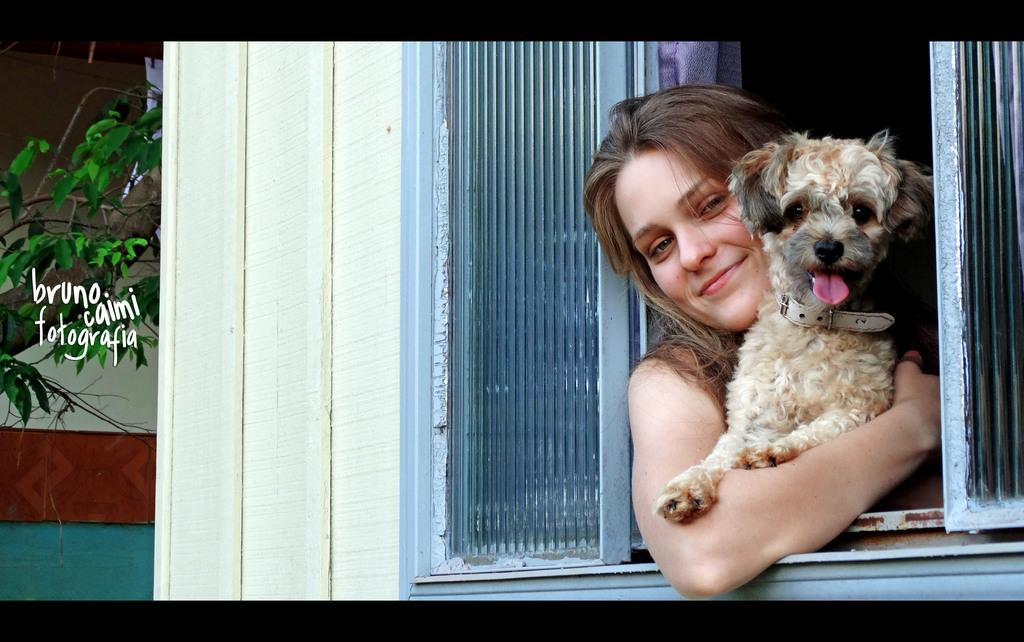Who is present in the image? There is a lady in the image. What is the lady holding in the image? The lady is holding a dog. Where are they located in the image? They are out from a window. What can be seen in the background of the image? There is a tree visible in the image. What type of bird can be seen flying around the lady and the dog in the image? There is no bird present in the image; it only features a lady holding a dog and a tree in the background. 